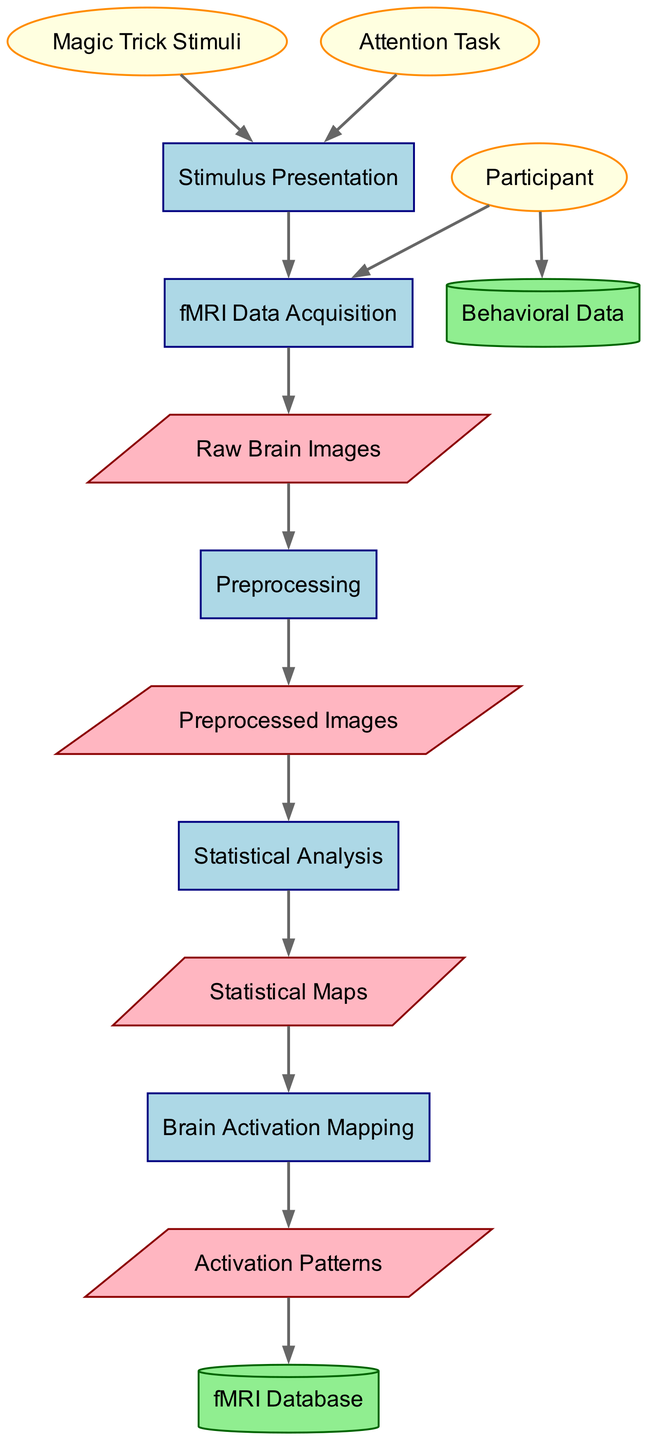What is the first process in the fMRI data analysis workflow? The first process listed in the diagram is "Stimulus Presentation", which starts the flow of data and sequences the upcoming steps that follow in the analysis.
Answer: Stimulus Presentation How many external entities are depicted in the diagram? The diagram shows three external entities: "Participant", "Magic Trick Stimuli", and "Attention Task". Thus, counting them gives a total of three.
Answer: 3 Which data flow comes after "Raw Brain Images"? The data flow that follows "Raw Brain Images" is "Preprocessing", indicating that raw images undergo preparation before further analysis.
Answer: Preprocessing What type of data store is "fMRI Database"? "fMRI Database" is represented as a cylinder in the diagram, which is the standard shape used for data stores, indicating it is a storage repository for fMRI-related data.
Answer: Cylinder What flows into "Statistical Analysis"? The data flow "Preprocessed Images" goes into "Statistical Analysis", meaning the analysis will process only images that have been preprocessed and cleaned before statistical tests are applied.
Answer: Preprocessed Images How many processes exist in the diagram? The diagram contains five processes; those are: "Stimulus Presentation", "fMRI Data Acquisition", "Preprocessing", "Statistical Analysis", and "Brain Activation Mapping".
Answer: 5 What kind of data flows to the "fMRI Database"? The data flow "Activation Patterns" is the output from "Brain Activation Mapping" and is directed into "fMRI Database," signifying a data storage operation based on the activation patterns found during analysis.
Answer: Activation Patterns What is the last process in the workflow? The final process is "Brain Activation Mapping", which follows all previous steps and represents the phase where brain activations are visually represented and mapped based on the analyses performed earlier.
Answer: Brain Activation Mapping Which external entity is connected to both "fMRI Data Acquisition" and "Behavioral Data"? The "Participant" is the external entity linked to both "fMRI Data Acquisition" and "Behavioral Data", indicating that participant involvement yields data for both imaging and behavioral aspects of the study.
Answer: Participant 